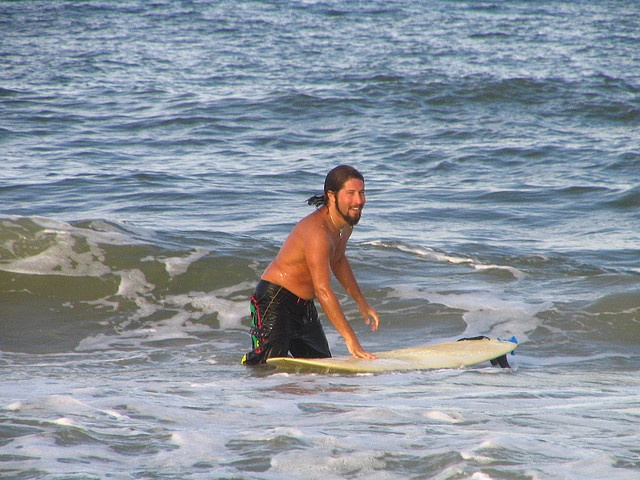Describe the objects in this image and their specific colors. I can see people in gray, black, brown, and salmon tones and surfboard in gray, tan, lightgray, and darkgray tones in this image. 